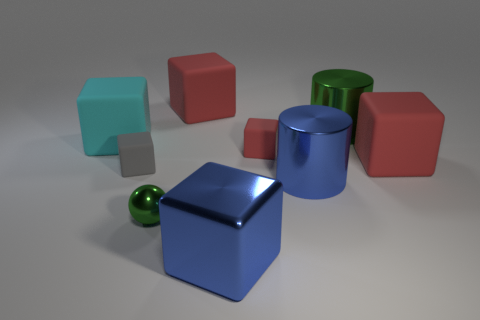Subtract all red blocks. How many were subtracted if there are1red blocks left? 2 Subtract all gray cubes. How many cubes are left? 5 Subtract all blue cylinders. How many red cubes are left? 3 Subtract all blue blocks. How many blocks are left? 5 Add 1 tiny gray blocks. How many objects exist? 10 Subtract 0 red spheres. How many objects are left? 9 Subtract all spheres. How many objects are left? 8 Subtract all brown cylinders. Subtract all cyan spheres. How many cylinders are left? 2 Subtract all brown matte things. Subtract all cyan matte things. How many objects are left? 8 Add 3 large cyan things. How many large cyan things are left? 4 